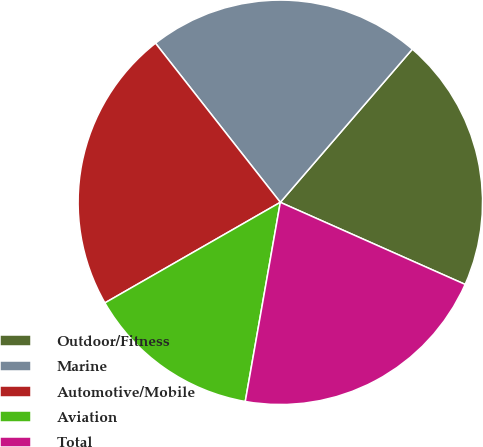<chart> <loc_0><loc_0><loc_500><loc_500><pie_chart><fcel>Outdoor/Fitness<fcel>Marine<fcel>Automotive/Mobile<fcel>Aviation<fcel>Total<nl><fcel>20.33%<fcel>21.91%<fcel>22.7%<fcel>13.94%<fcel>21.12%<nl></chart> 